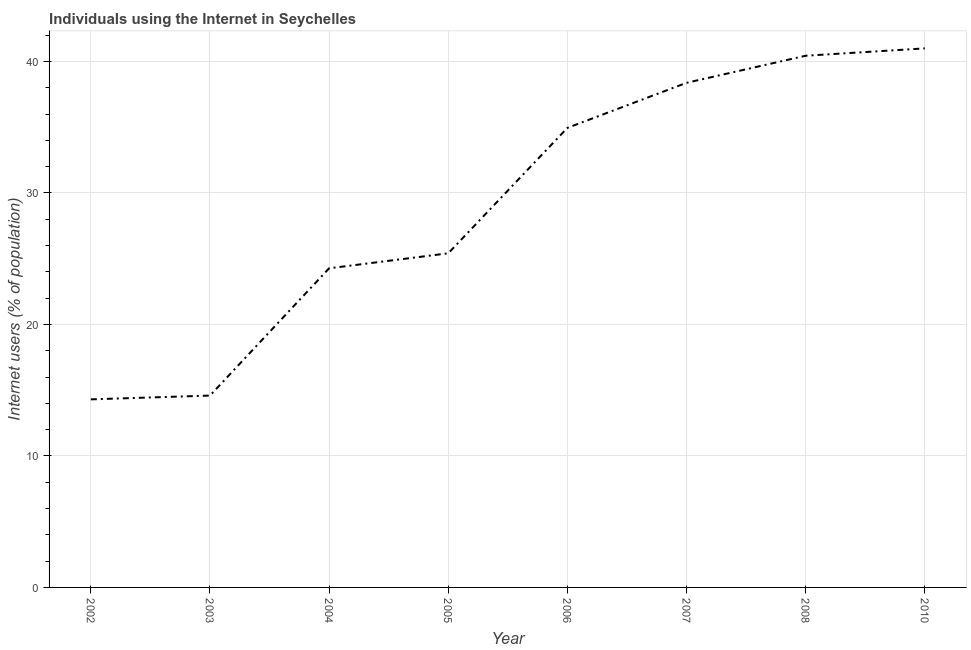What is the number of internet users in 2006?
Give a very brief answer. 34.95. Across all years, what is the minimum number of internet users?
Provide a succinct answer. 14.3. In which year was the number of internet users maximum?
Make the answer very short. 2010. In which year was the number of internet users minimum?
Give a very brief answer. 2002. What is the sum of the number of internet users?
Give a very brief answer. 233.35. What is the difference between the number of internet users in 2003 and 2005?
Offer a very short reply. -10.82. What is the average number of internet users per year?
Give a very brief answer. 29.17. What is the median number of internet users?
Offer a very short reply. 30.18. Do a majority of the years between 2006 and 2007 (inclusive) have number of internet users greater than 36 %?
Provide a succinct answer. No. What is the ratio of the number of internet users in 2002 to that in 2008?
Ensure brevity in your answer.  0.35. Is the number of internet users in 2002 less than that in 2008?
Keep it short and to the point. Yes. Is the difference between the number of internet users in 2003 and 2004 greater than the difference between any two years?
Make the answer very short. No. What is the difference between the highest and the second highest number of internet users?
Your response must be concise. 0.56. Is the sum of the number of internet users in 2004 and 2010 greater than the maximum number of internet users across all years?
Offer a very short reply. Yes. What is the difference between the highest and the lowest number of internet users?
Provide a succinct answer. 26.7. In how many years, is the number of internet users greater than the average number of internet users taken over all years?
Provide a short and direct response. 4. Does the number of internet users monotonically increase over the years?
Make the answer very short. Yes. How many lines are there?
Your response must be concise. 1. How many years are there in the graph?
Your answer should be compact. 8. What is the difference between two consecutive major ticks on the Y-axis?
Your answer should be compact. 10. What is the title of the graph?
Keep it short and to the point. Individuals using the Internet in Seychelles. What is the label or title of the X-axis?
Your answer should be very brief. Year. What is the label or title of the Y-axis?
Your answer should be very brief. Internet users (% of population). What is the Internet users (% of population) of 2002?
Offer a very short reply. 14.3. What is the Internet users (% of population) of 2003?
Your answer should be very brief. 14.59. What is the Internet users (% of population) in 2004?
Keep it short and to the point. 24.27. What is the Internet users (% of population) in 2005?
Your answer should be compact. 25.41. What is the Internet users (% of population) of 2006?
Keep it short and to the point. 34.95. What is the Internet users (% of population) in 2007?
Keep it short and to the point. 38.38. What is the Internet users (% of population) of 2008?
Provide a short and direct response. 40.44. What is the Internet users (% of population) of 2010?
Provide a short and direct response. 41. What is the difference between the Internet users (% of population) in 2002 and 2003?
Give a very brief answer. -0.29. What is the difference between the Internet users (% of population) in 2002 and 2004?
Ensure brevity in your answer.  -9.97. What is the difference between the Internet users (% of population) in 2002 and 2005?
Offer a terse response. -11.11. What is the difference between the Internet users (% of population) in 2002 and 2006?
Make the answer very short. -20.65. What is the difference between the Internet users (% of population) in 2002 and 2007?
Your answer should be very brief. -24.08. What is the difference between the Internet users (% of population) in 2002 and 2008?
Provide a short and direct response. -26.14. What is the difference between the Internet users (% of population) in 2002 and 2010?
Give a very brief answer. -26.7. What is the difference between the Internet users (% of population) in 2003 and 2004?
Give a very brief answer. -9.68. What is the difference between the Internet users (% of population) in 2003 and 2005?
Make the answer very short. -10.82. What is the difference between the Internet users (% of population) in 2003 and 2006?
Your answer should be very brief. -20.36. What is the difference between the Internet users (% of population) in 2003 and 2007?
Offer a terse response. -23.79. What is the difference between the Internet users (% of population) in 2003 and 2008?
Offer a very short reply. -25.85. What is the difference between the Internet users (% of population) in 2003 and 2010?
Make the answer very short. -26.41. What is the difference between the Internet users (% of population) in 2004 and 2005?
Provide a succinct answer. -1.14. What is the difference between the Internet users (% of population) in 2004 and 2006?
Offer a terse response. -10.68. What is the difference between the Internet users (% of population) in 2004 and 2007?
Your answer should be compact. -14.11. What is the difference between the Internet users (% of population) in 2004 and 2008?
Make the answer very short. -16.17. What is the difference between the Internet users (% of population) in 2004 and 2010?
Offer a very short reply. -16.73. What is the difference between the Internet users (% of population) in 2005 and 2006?
Make the answer very short. -9.54. What is the difference between the Internet users (% of population) in 2005 and 2007?
Keep it short and to the point. -12.97. What is the difference between the Internet users (% of population) in 2005 and 2008?
Make the answer very short. -15.03. What is the difference between the Internet users (% of population) in 2005 and 2010?
Give a very brief answer. -15.59. What is the difference between the Internet users (% of population) in 2006 and 2007?
Your answer should be very brief. -3.43. What is the difference between the Internet users (% of population) in 2006 and 2008?
Your response must be concise. -5.49. What is the difference between the Internet users (% of population) in 2006 and 2010?
Give a very brief answer. -6.05. What is the difference between the Internet users (% of population) in 2007 and 2008?
Make the answer very short. -2.06. What is the difference between the Internet users (% of population) in 2007 and 2010?
Ensure brevity in your answer.  -2.62. What is the difference between the Internet users (% of population) in 2008 and 2010?
Your response must be concise. -0.56. What is the ratio of the Internet users (% of population) in 2002 to that in 2003?
Keep it short and to the point. 0.98. What is the ratio of the Internet users (% of population) in 2002 to that in 2004?
Your answer should be very brief. 0.59. What is the ratio of the Internet users (% of population) in 2002 to that in 2005?
Provide a succinct answer. 0.56. What is the ratio of the Internet users (% of population) in 2002 to that in 2006?
Your answer should be very brief. 0.41. What is the ratio of the Internet users (% of population) in 2002 to that in 2007?
Keep it short and to the point. 0.37. What is the ratio of the Internet users (% of population) in 2002 to that in 2008?
Offer a very short reply. 0.35. What is the ratio of the Internet users (% of population) in 2002 to that in 2010?
Offer a terse response. 0.35. What is the ratio of the Internet users (% of population) in 2003 to that in 2004?
Offer a very short reply. 0.6. What is the ratio of the Internet users (% of population) in 2003 to that in 2005?
Your response must be concise. 0.57. What is the ratio of the Internet users (% of population) in 2003 to that in 2006?
Make the answer very short. 0.42. What is the ratio of the Internet users (% of population) in 2003 to that in 2007?
Make the answer very short. 0.38. What is the ratio of the Internet users (% of population) in 2003 to that in 2008?
Give a very brief answer. 0.36. What is the ratio of the Internet users (% of population) in 2003 to that in 2010?
Provide a succinct answer. 0.36. What is the ratio of the Internet users (% of population) in 2004 to that in 2005?
Ensure brevity in your answer.  0.95. What is the ratio of the Internet users (% of population) in 2004 to that in 2006?
Your answer should be compact. 0.69. What is the ratio of the Internet users (% of population) in 2004 to that in 2007?
Your answer should be compact. 0.63. What is the ratio of the Internet users (% of population) in 2004 to that in 2008?
Ensure brevity in your answer.  0.6. What is the ratio of the Internet users (% of population) in 2004 to that in 2010?
Give a very brief answer. 0.59. What is the ratio of the Internet users (% of population) in 2005 to that in 2006?
Provide a short and direct response. 0.73. What is the ratio of the Internet users (% of population) in 2005 to that in 2007?
Keep it short and to the point. 0.66. What is the ratio of the Internet users (% of population) in 2005 to that in 2008?
Your response must be concise. 0.63. What is the ratio of the Internet users (% of population) in 2005 to that in 2010?
Keep it short and to the point. 0.62. What is the ratio of the Internet users (% of population) in 2006 to that in 2007?
Your response must be concise. 0.91. What is the ratio of the Internet users (% of population) in 2006 to that in 2008?
Give a very brief answer. 0.86. What is the ratio of the Internet users (% of population) in 2006 to that in 2010?
Ensure brevity in your answer.  0.85. What is the ratio of the Internet users (% of population) in 2007 to that in 2008?
Make the answer very short. 0.95. What is the ratio of the Internet users (% of population) in 2007 to that in 2010?
Provide a succinct answer. 0.94. 